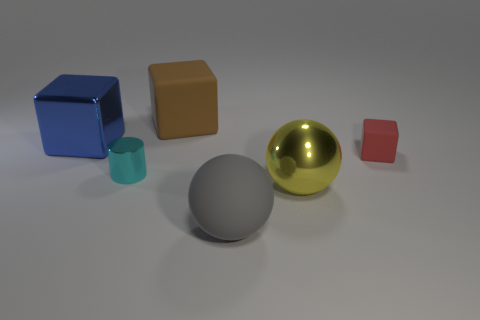Subtract all large shiny cubes. How many cubes are left? 2 Add 2 tiny red matte cubes. How many objects exist? 8 Subtract all cyan cubes. Subtract all gray balls. How many cubes are left? 3 Add 4 gray balls. How many gray balls are left? 5 Add 5 blue blocks. How many blue blocks exist? 6 Subtract 0 yellow cylinders. How many objects are left? 6 Subtract all spheres. How many objects are left? 4 Subtract all large matte blocks. Subtract all red matte blocks. How many objects are left? 4 